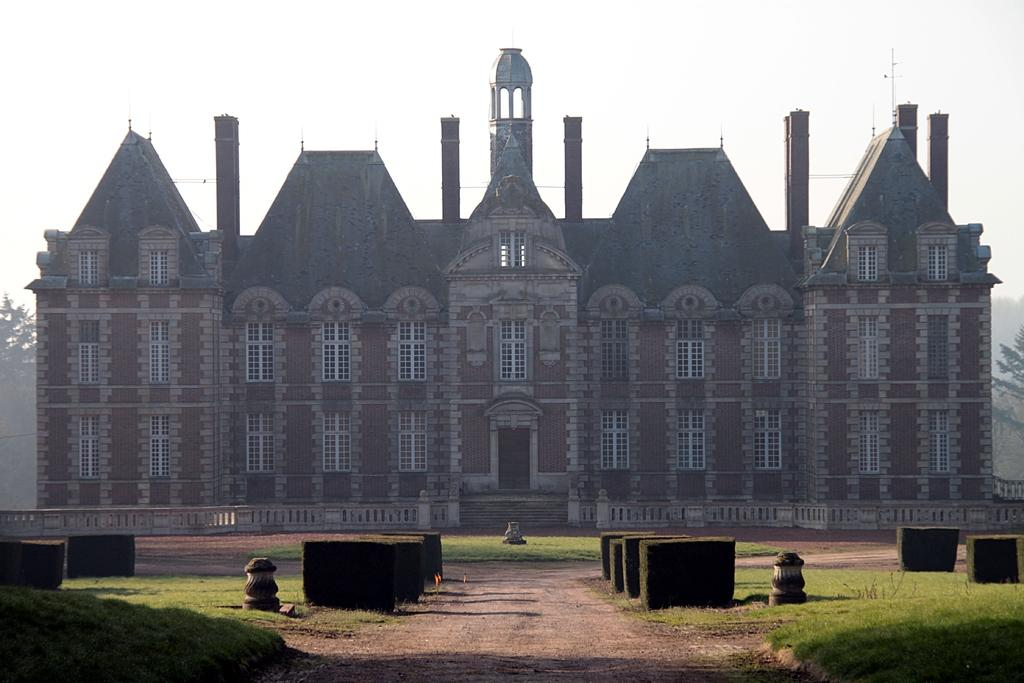What type of structure is present in the image? There is a building in the image. What is located in front of the building? There is grass in front of the building. What can be seen in the background of the image? There are trees visible in the background of the image. What type of riddle is being solved by the trees in the image? There is no riddle being solved by the trees in the image; they are simply visible in the background. 